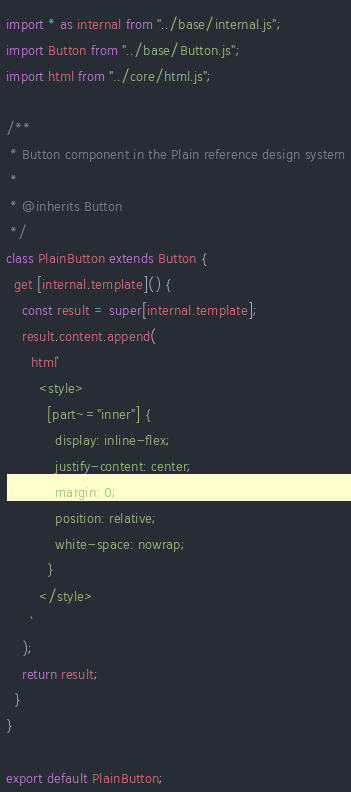Convert code to text. <code><loc_0><loc_0><loc_500><loc_500><_JavaScript_>import * as internal from "../base/internal.js";
import Button from "../base/Button.js";
import html from "../core/html.js";

/**
 * Button component in the Plain reference design system
 *
 * @inherits Button
 */
class PlainButton extends Button {
  get [internal.template]() {
    const result = super[internal.template];
    result.content.append(
      html`
        <style>
          [part~="inner"] {
            display: inline-flex;
            justify-content: center;
            margin: 0;
            position: relative;
            white-space: nowrap;
          }
        </style>
      `
    );
    return result;
  }
}

export default PlainButton;
</code> 